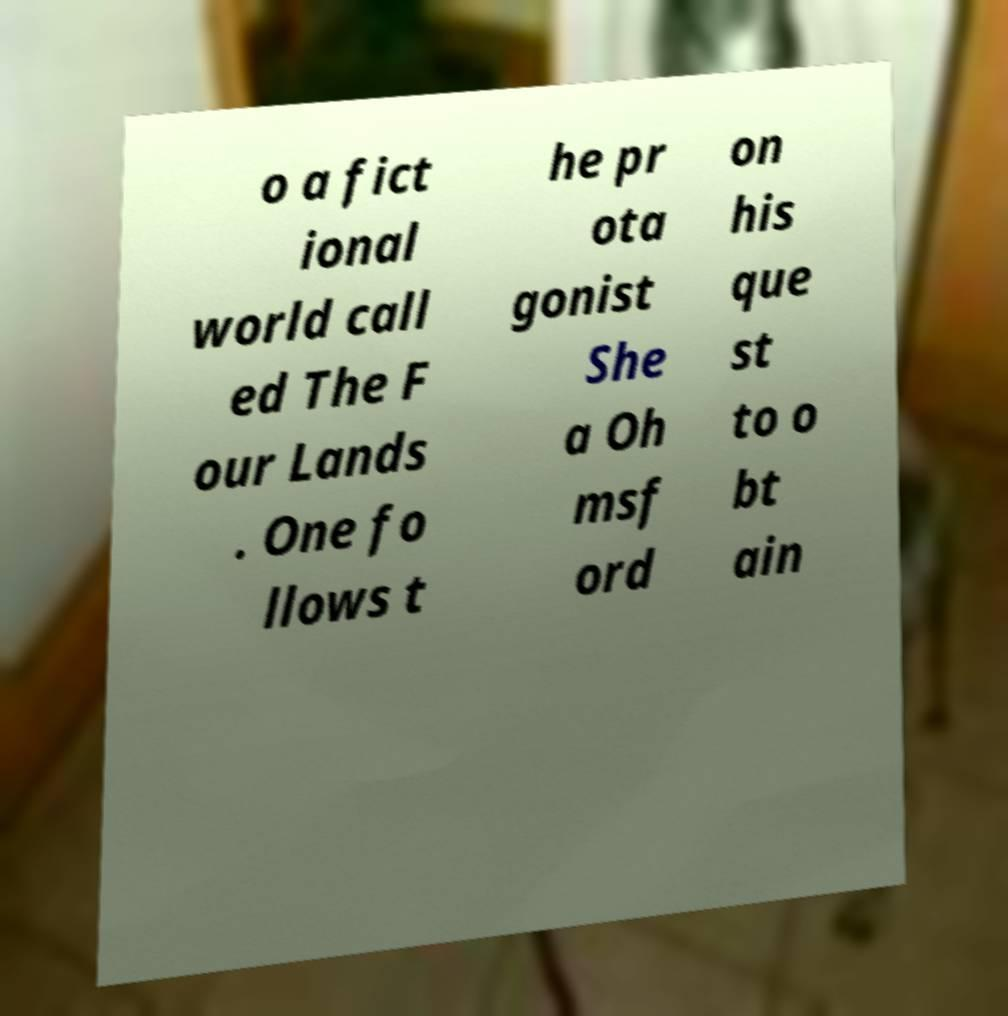I need the written content from this picture converted into text. Can you do that? o a fict ional world call ed The F our Lands . One fo llows t he pr ota gonist She a Oh msf ord on his que st to o bt ain 